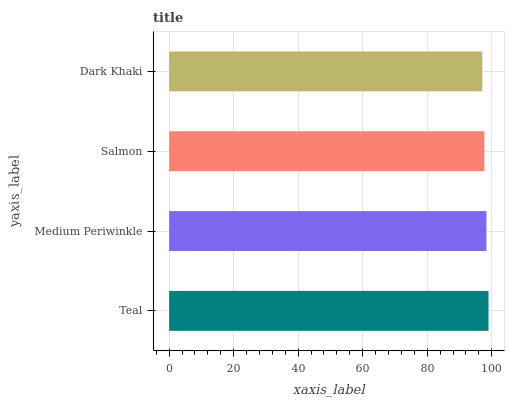Is Dark Khaki the minimum?
Answer yes or no. Yes. Is Teal the maximum?
Answer yes or no. Yes. Is Medium Periwinkle the minimum?
Answer yes or no. No. Is Medium Periwinkle the maximum?
Answer yes or no. No. Is Teal greater than Medium Periwinkle?
Answer yes or no. Yes. Is Medium Periwinkle less than Teal?
Answer yes or no. Yes. Is Medium Periwinkle greater than Teal?
Answer yes or no. No. Is Teal less than Medium Periwinkle?
Answer yes or no. No. Is Medium Periwinkle the high median?
Answer yes or no. Yes. Is Salmon the low median?
Answer yes or no. Yes. Is Salmon the high median?
Answer yes or no. No. Is Dark Khaki the low median?
Answer yes or no. No. 